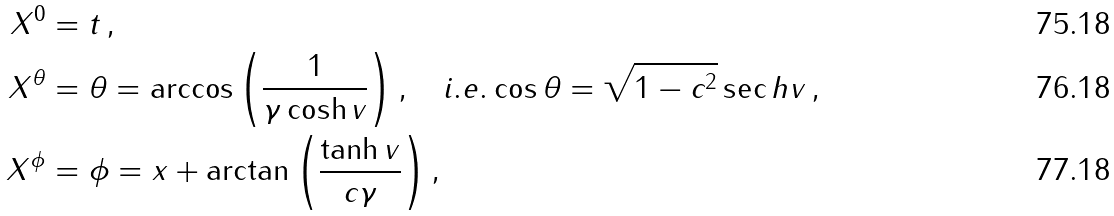<formula> <loc_0><loc_0><loc_500><loc_500>X ^ { 0 } & = t \, , \\ X ^ { \theta } & = \theta = \arccos \left ( \frac { 1 } { \gamma \cosh v } \right ) , \quad i . e . \cos \theta = \sqrt { 1 - c ^ { 2 } } \sec h v \, , \\ X ^ { \phi } & = \phi = x + \arctan \left ( \frac { \tanh v } { c \gamma } \right ) ,</formula> 